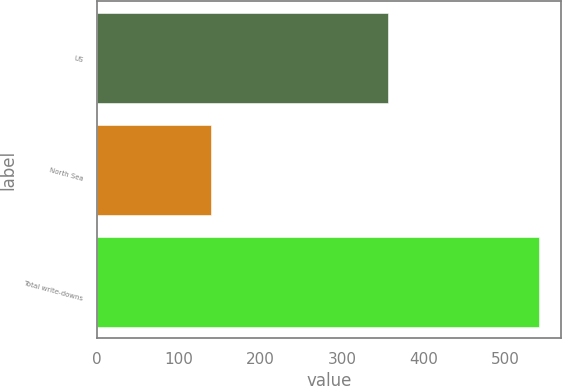Convert chart to OTSL. <chart><loc_0><loc_0><loc_500><loc_500><bar_chart><fcel>US<fcel>North Sea<fcel>Total write-downs<nl><fcel>356<fcel>139<fcel>541<nl></chart> 